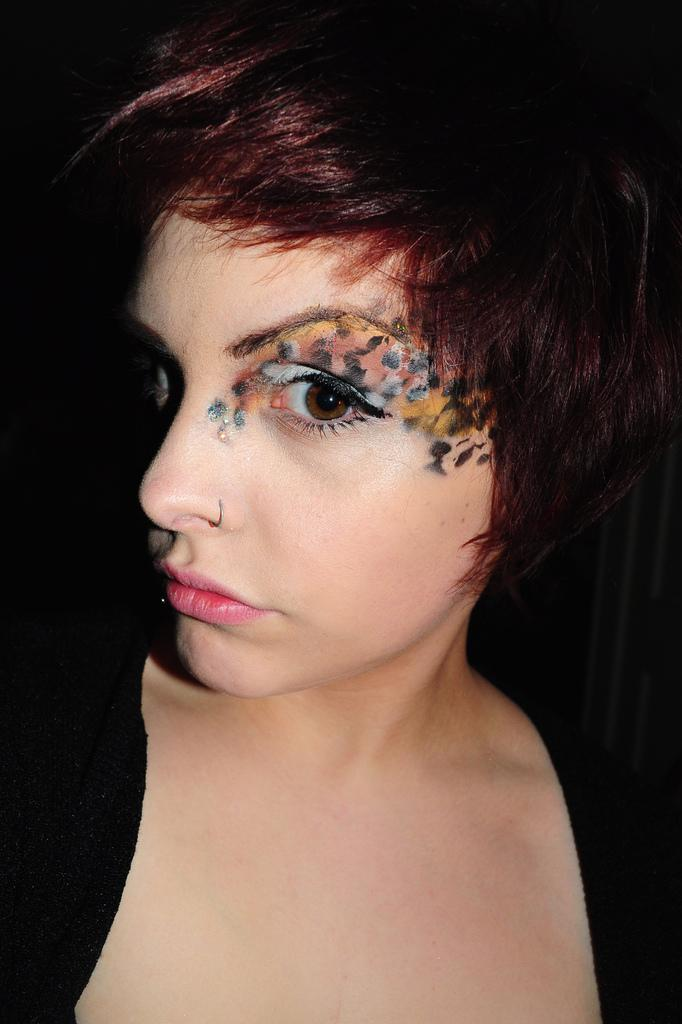Who is present in the image? There is a woman in the image. What is the woman wearing in the image? The woman is wearing a black dress in the image. Are there any accessories visible on the woman in the image? Yes, the woman is wearing a nose ring in the image. What type of goldfish can be seen swimming in the image? There are no goldfish present in the image. Is there any indication of hate or animosity in the image? The image does not show any signs of hate or animosity. 